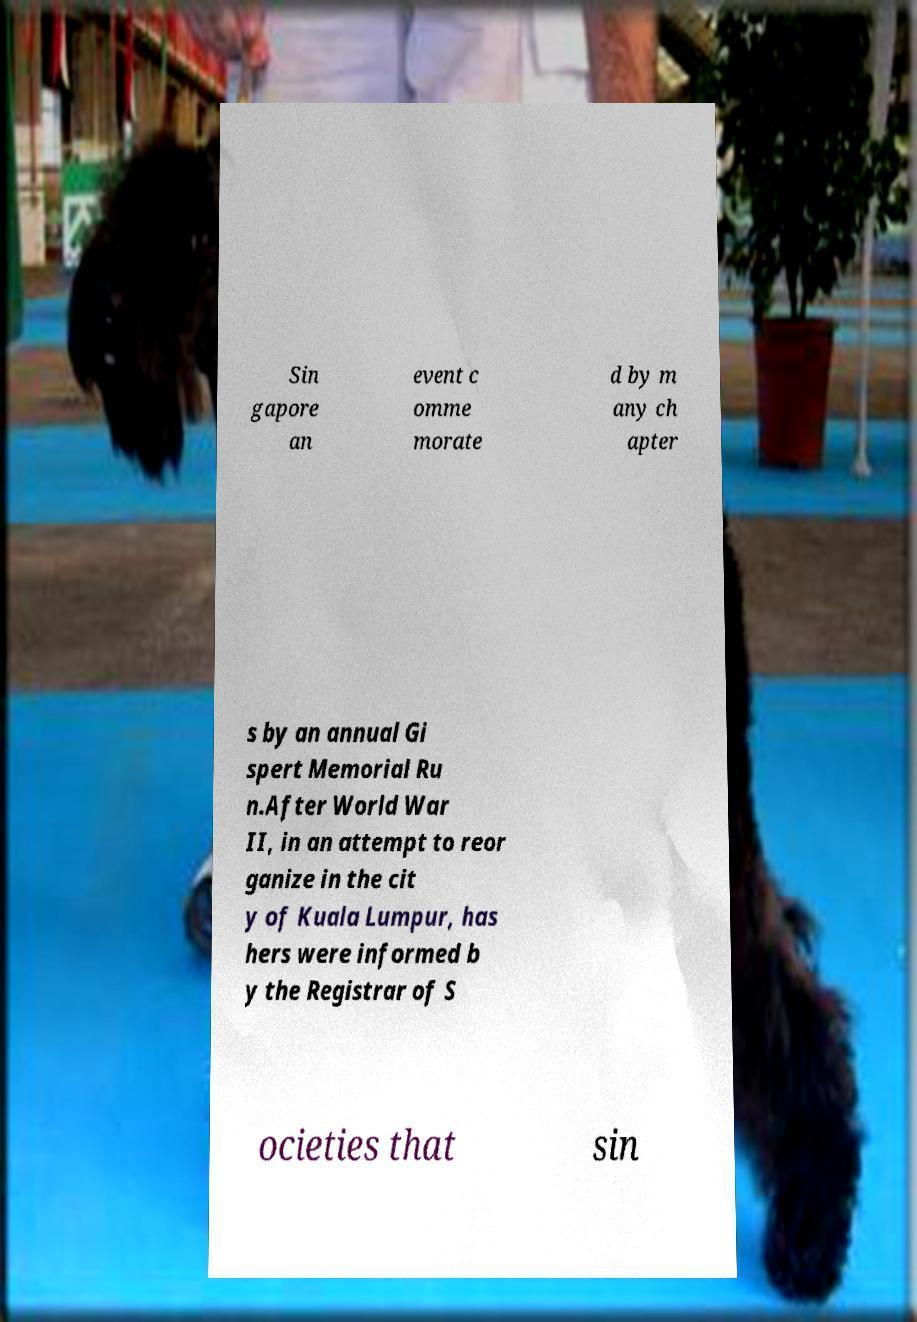Please identify and transcribe the text found in this image. Sin gapore an event c omme morate d by m any ch apter s by an annual Gi spert Memorial Ru n.After World War II, in an attempt to reor ganize in the cit y of Kuala Lumpur, has hers were informed b y the Registrar of S ocieties that sin 